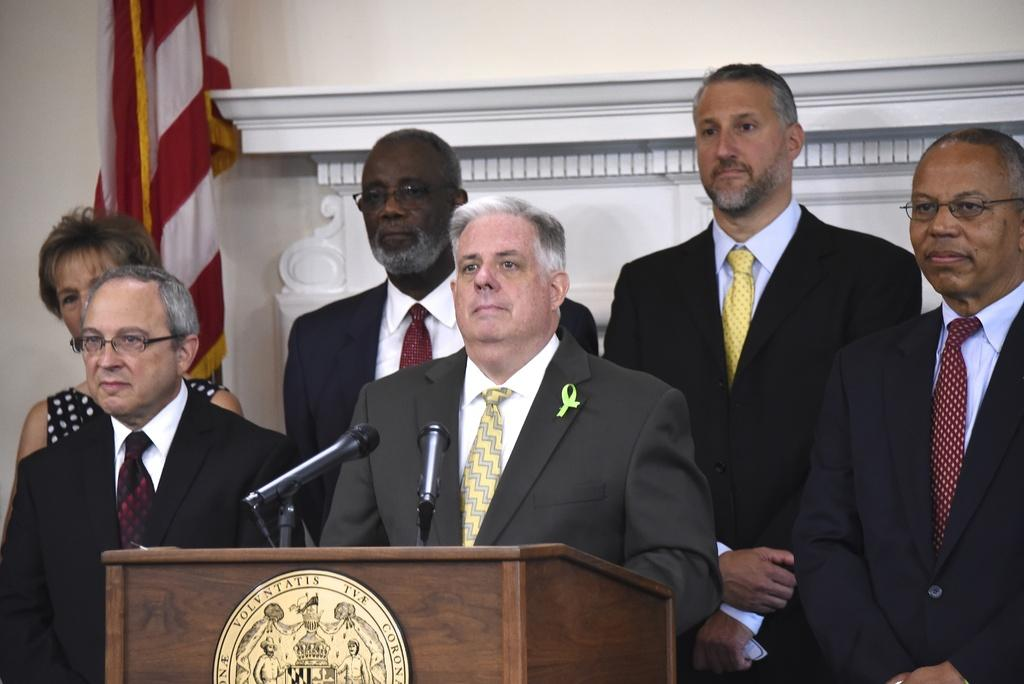How many people are in the image? There are persons in the image, but the exact number is not specified. What is the man in the image doing? The man is standing in front of a microphone. What object is present in the image that is often used for speeches or presentations? There is a podium in the image. What can be seen in the background of the image? There is a wall and a flag in the background of the image. What type of juice is being served at the event in the image? There is no mention of juice or an event in the image, so it cannot be determined from the image. 